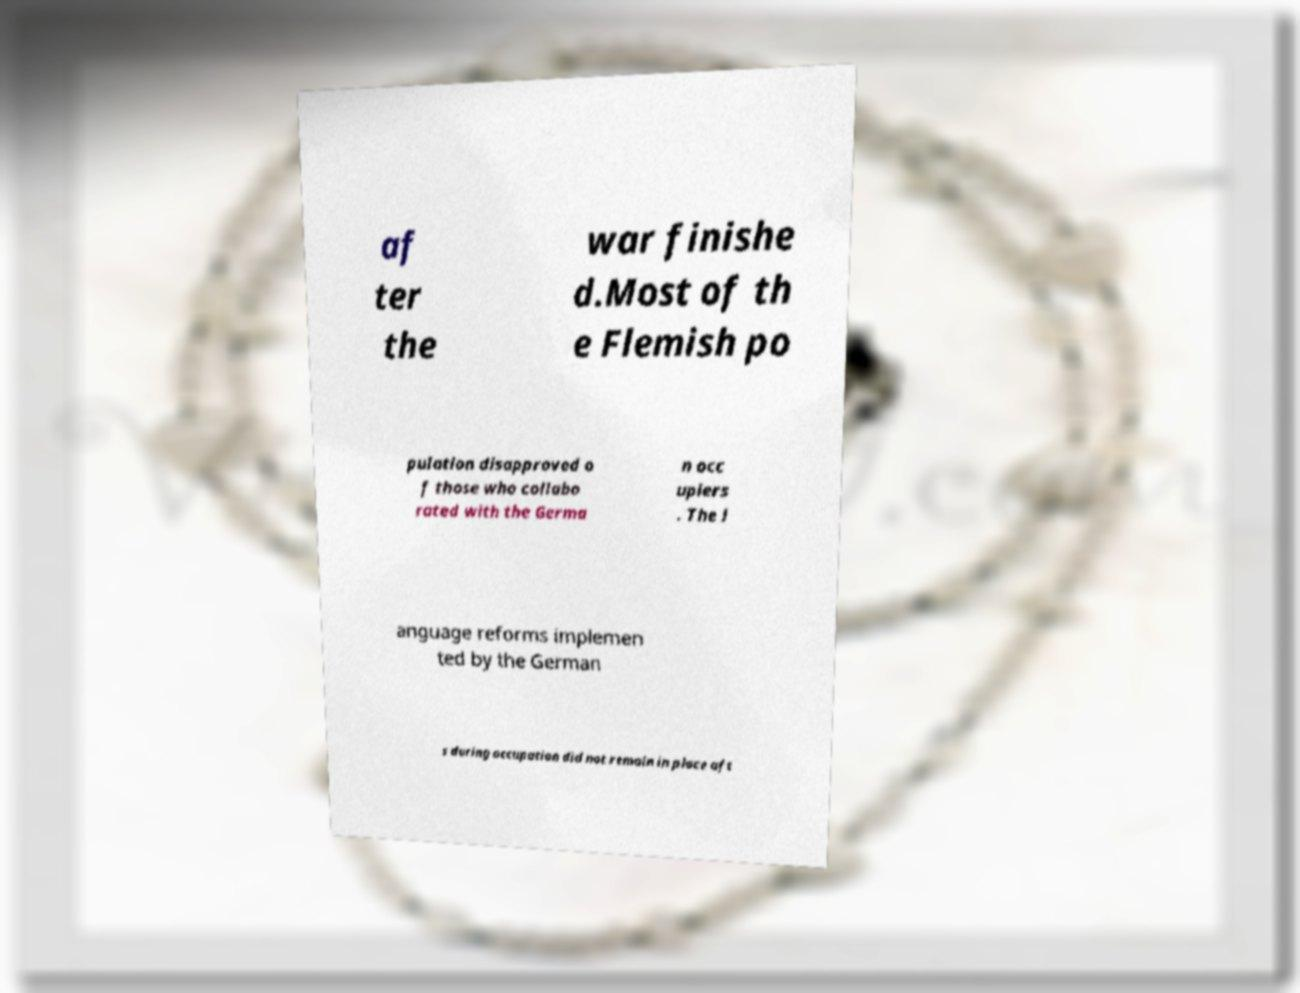Please identify and transcribe the text found in this image. af ter the war finishe d.Most of th e Flemish po pulation disapproved o f those who collabo rated with the Germa n occ upiers . The l anguage reforms implemen ted by the German s during occupation did not remain in place aft 